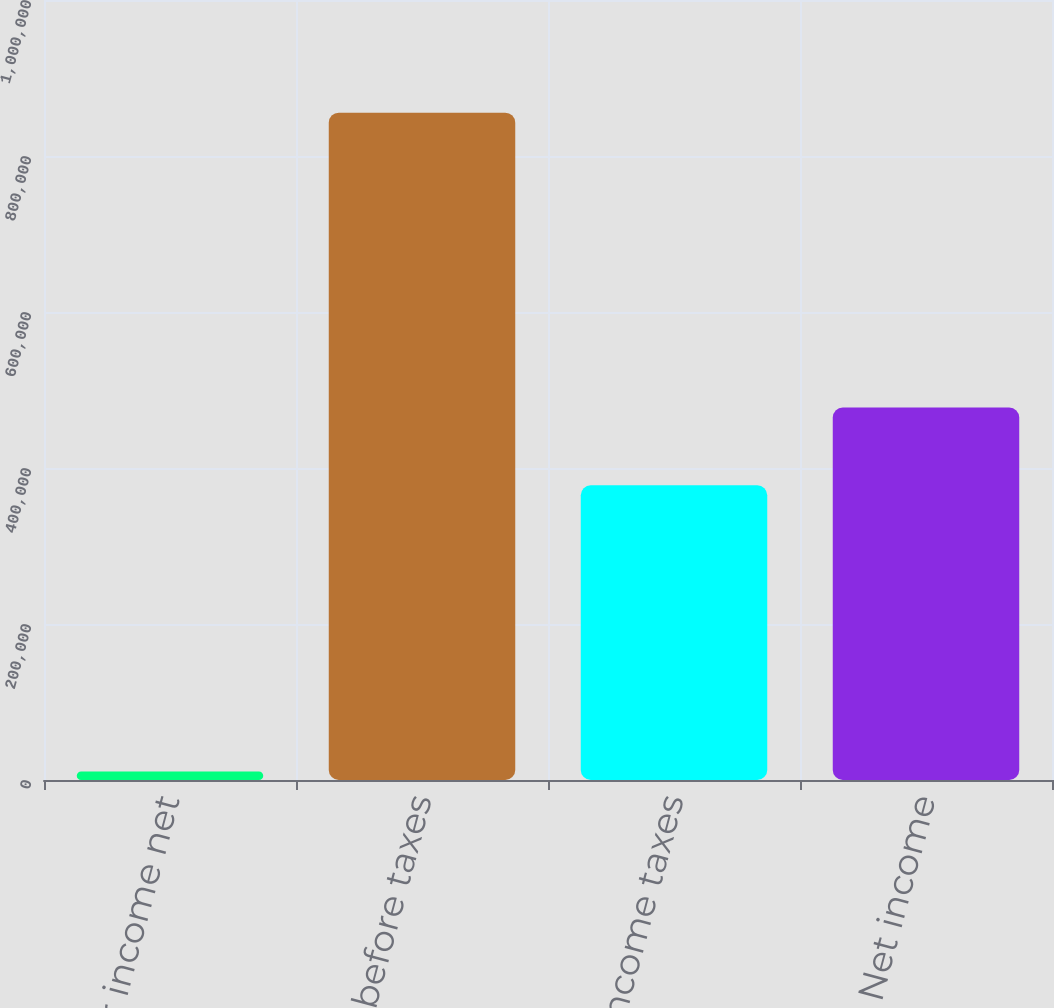Convert chart to OTSL. <chart><loc_0><loc_0><loc_500><loc_500><bar_chart><fcel>Other income net<fcel>Income before taxes<fcel>Income taxes<fcel>Net income<nl><fcel>10962<fcel>855564<fcel>377949<fcel>477615<nl></chart> 